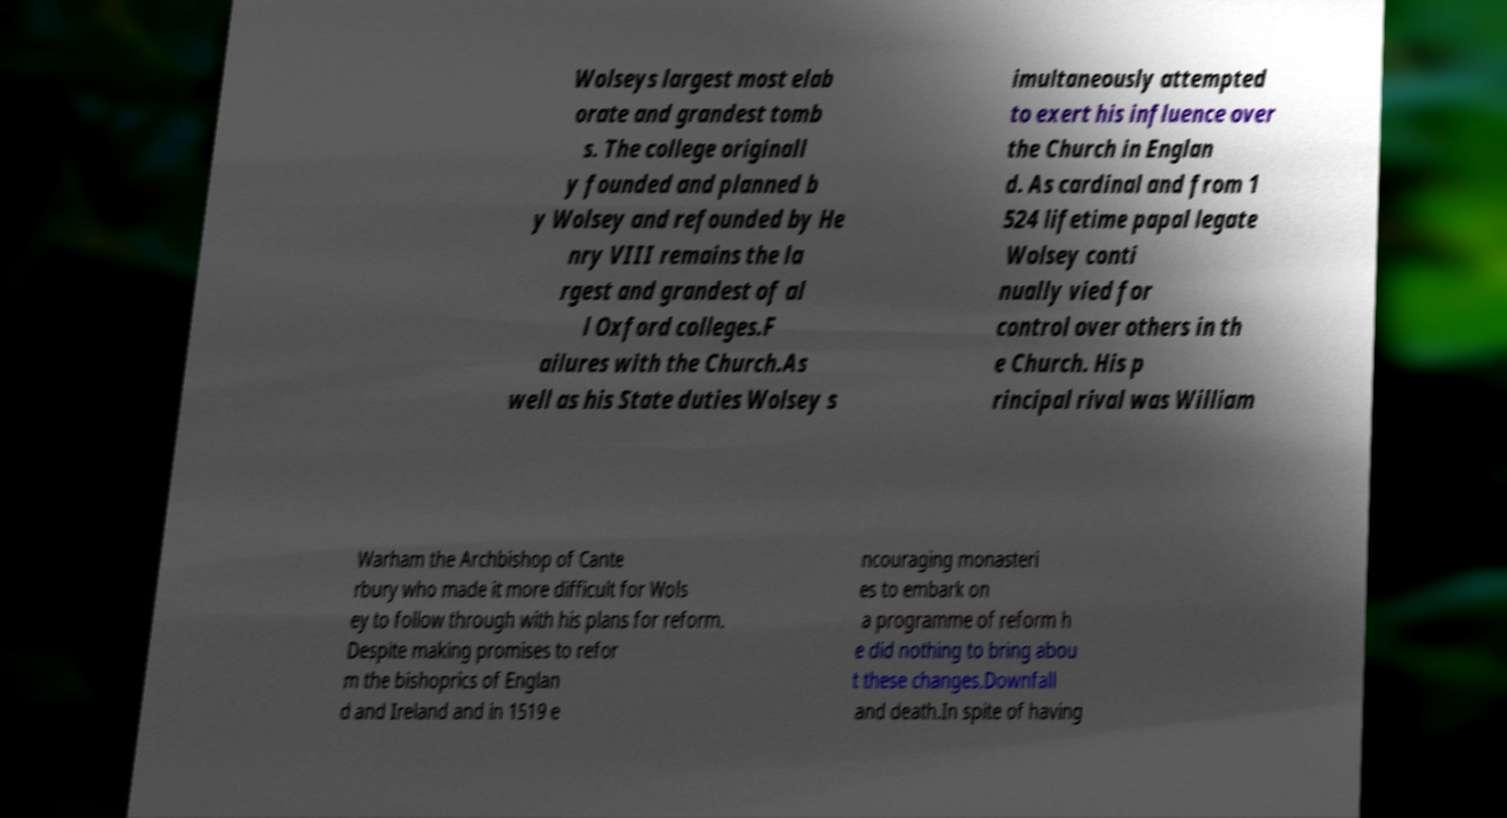Please identify and transcribe the text found in this image. Wolseys largest most elab orate and grandest tomb s. The college originall y founded and planned b y Wolsey and refounded by He nry VIII remains the la rgest and grandest of al l Oxford colleges.F ailures with the Church.As well as his State duties Wolsey s imultaneously attempted to exert his influence over the Church in Englan d. As cardinal and from 1 524 lifetime papal legate Wolsey conti nually vied for control over others in th e Church. His p rincipal rival was William Warham the Archbishop of Cante rbury who made it more difficult for Wols ey to follow through with his plans for reform. Despite making promises to refor m the bishoprics of Englan d and Ireland and in 1519 e ncouraging monasteri es to embark on a programme of reform h e did nothing to bring abou t these changes.Downfall and death.In spite of having 